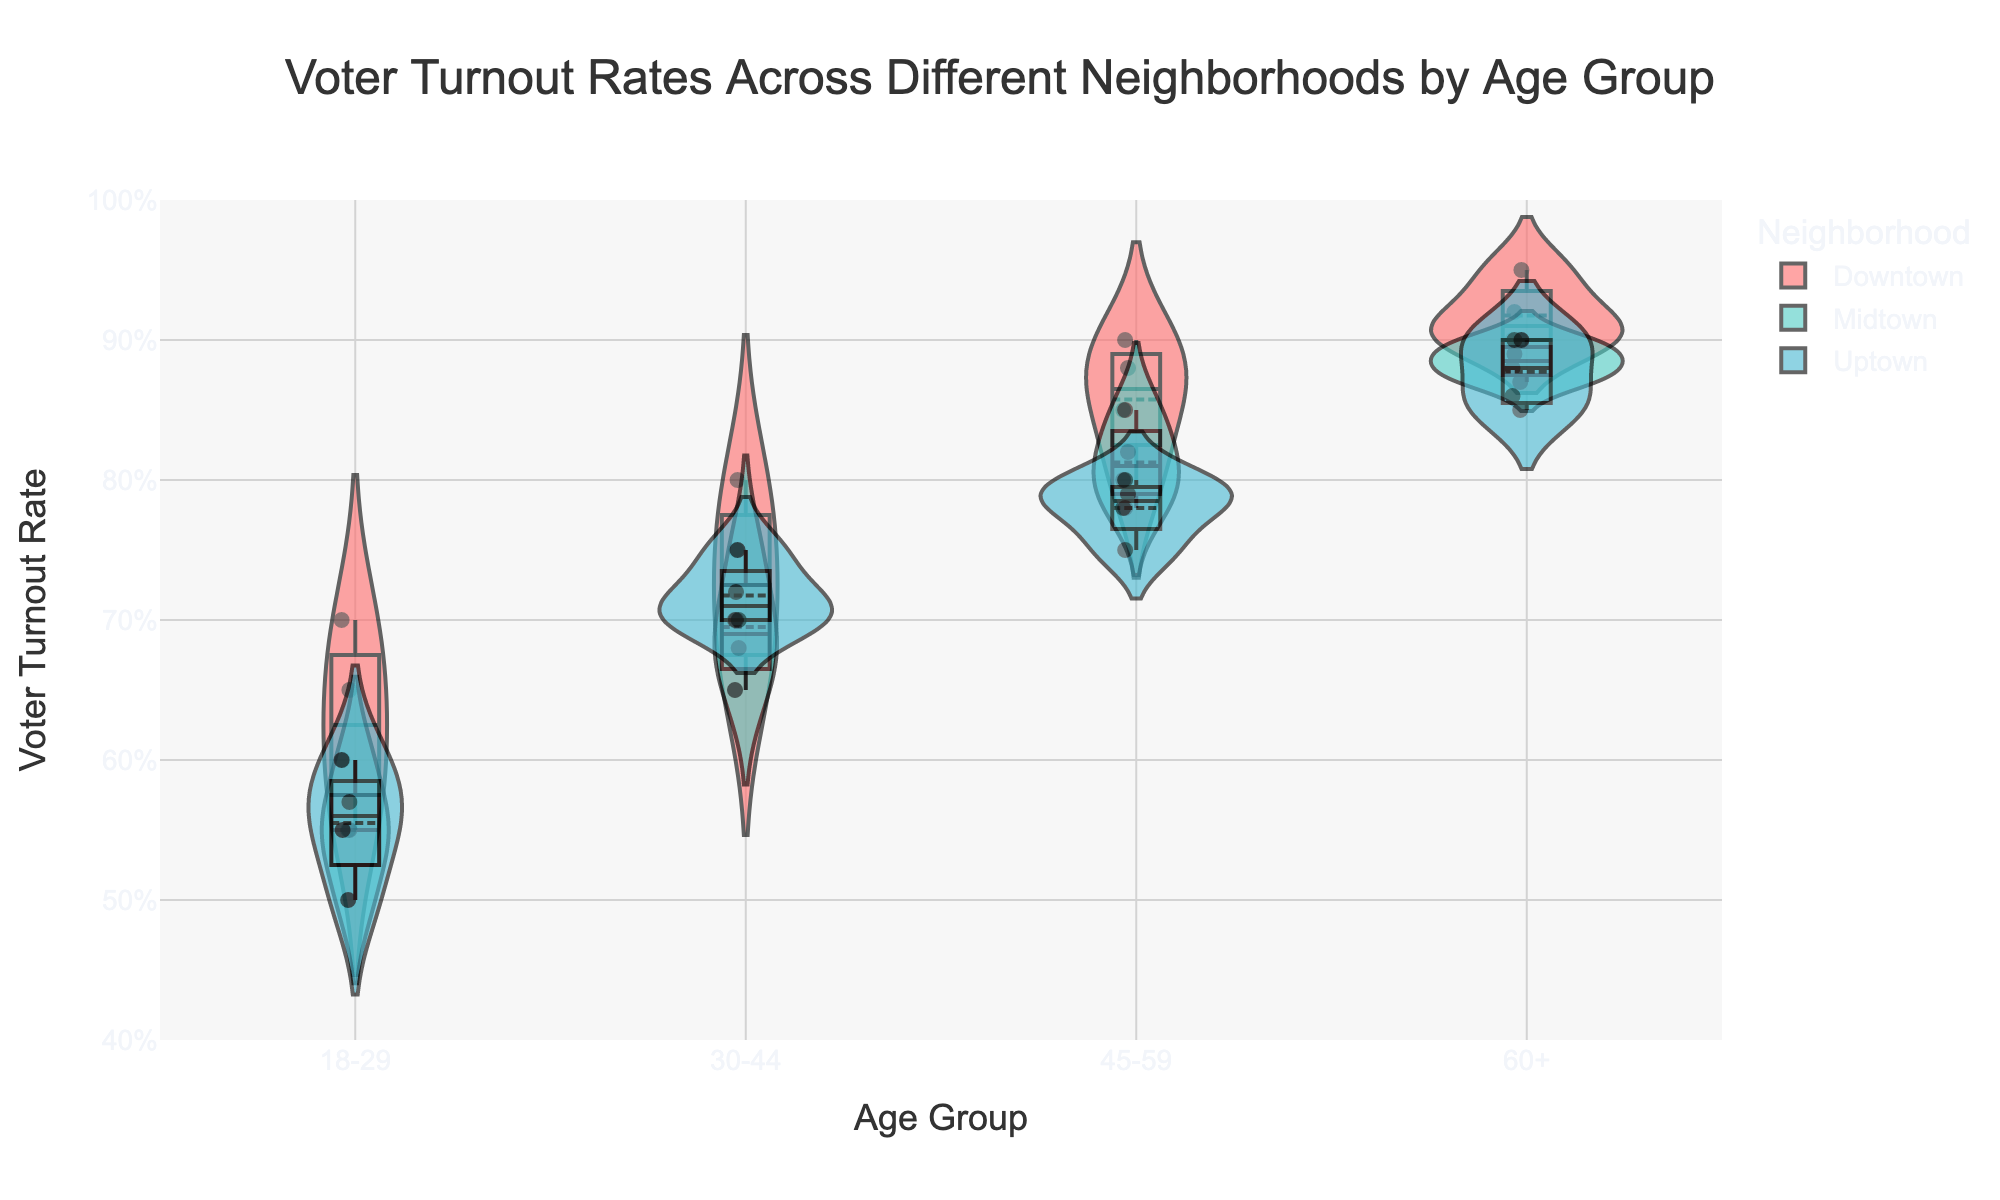What is the title of the figure? The title of the figure is a basic element that can be seen at the top of the chart.
Answer: Voter Turnout Rates Across Different Neighborhoods by Age Group What is the range of the y-axis? The y-axis range is generally indicated by the minimum and maximum tick marks on the vertical axis.
Answer: 0.4 to 1.0 Which neighborhood has the highest median voter turnout rate in the 60+ age group? The median voter turnout rate is indicated by the line inside the box plot within the violin plot.
Answer: Downtown What is the overall voter turnout trend by age group from 18-29 to 60+? Observing the violin plots' overall shapes and positions (mean lines), we can detect the trend.
Answer: Increasing Which neighborhood shows the widest spread of voter turnout rates in the 45-59 age group? The spread is indicated by the width of the violin plot and range of the box plot within it.
Answer: Downtown What's the mean voter turnout rate for Midtown in the 30-44 age group? The mean value is represented by the horizontal mean line within the box plot on the violin plot.
Answer: Around 0.7 Compare the voter turnout rates for the 18-29 age group among all neighborhoods. Which has the lowest values? Compare the lowest points (smallest values) indicated in the violin plots for the 18-29 age group across different neighborhoods.
Answer: Midtown Which age group in Uptown has the smallest variability in voter turnout rates? The smallest variability is represented by the narrowest violin plot and smallest range in the box plot.
Answer: 18-29 Which neighborhood has the most data points for the 30-44 age group? The number of data points can be discerned from the density and number of dots within and adjacent to the violin plot for the specific age group and neighborhood.
Answer: Downtown Do any neighborhoods show overlapping voter turnout rates for different age groups? If so, provide examples. Look for overlapping areas within the violin plots for different age groups within the same neighborhood.
Answer: Yes, Midtown and Uptown show overlapping between 45-59 and 60+ age groups 